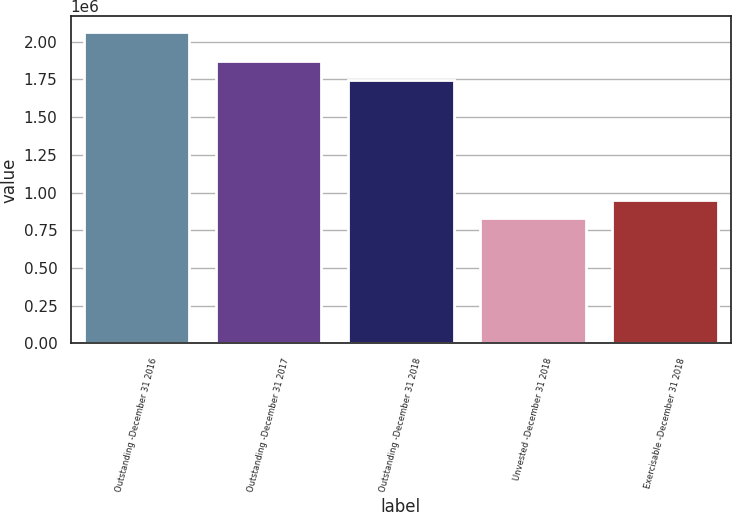Convert chart to OTSL. <chart><loc_0><loc_0><loc_500><loc_500><bar_chart><fcel>Outstanding -December 31 2016<fcel>Outstanding -December 31 2017<fcel>Outstanding -December 31 2018<fcel>Unvested -December 31 2018<fcel>Exercisable -December 31 2018<nl><fcel>2.06425e+06<fcel>1.87049e+06<fcel>1.74707e+06<fcel>830076<fcel>953494<nl></chart> 